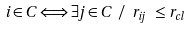<formula> <loc_0><loc_0><loc_500><loc_500>i \in C \Longleftrightarrow \exists j \in C \text { } / \text { } r _ { i j } \text { } \leq r _ { c l }</formula> 